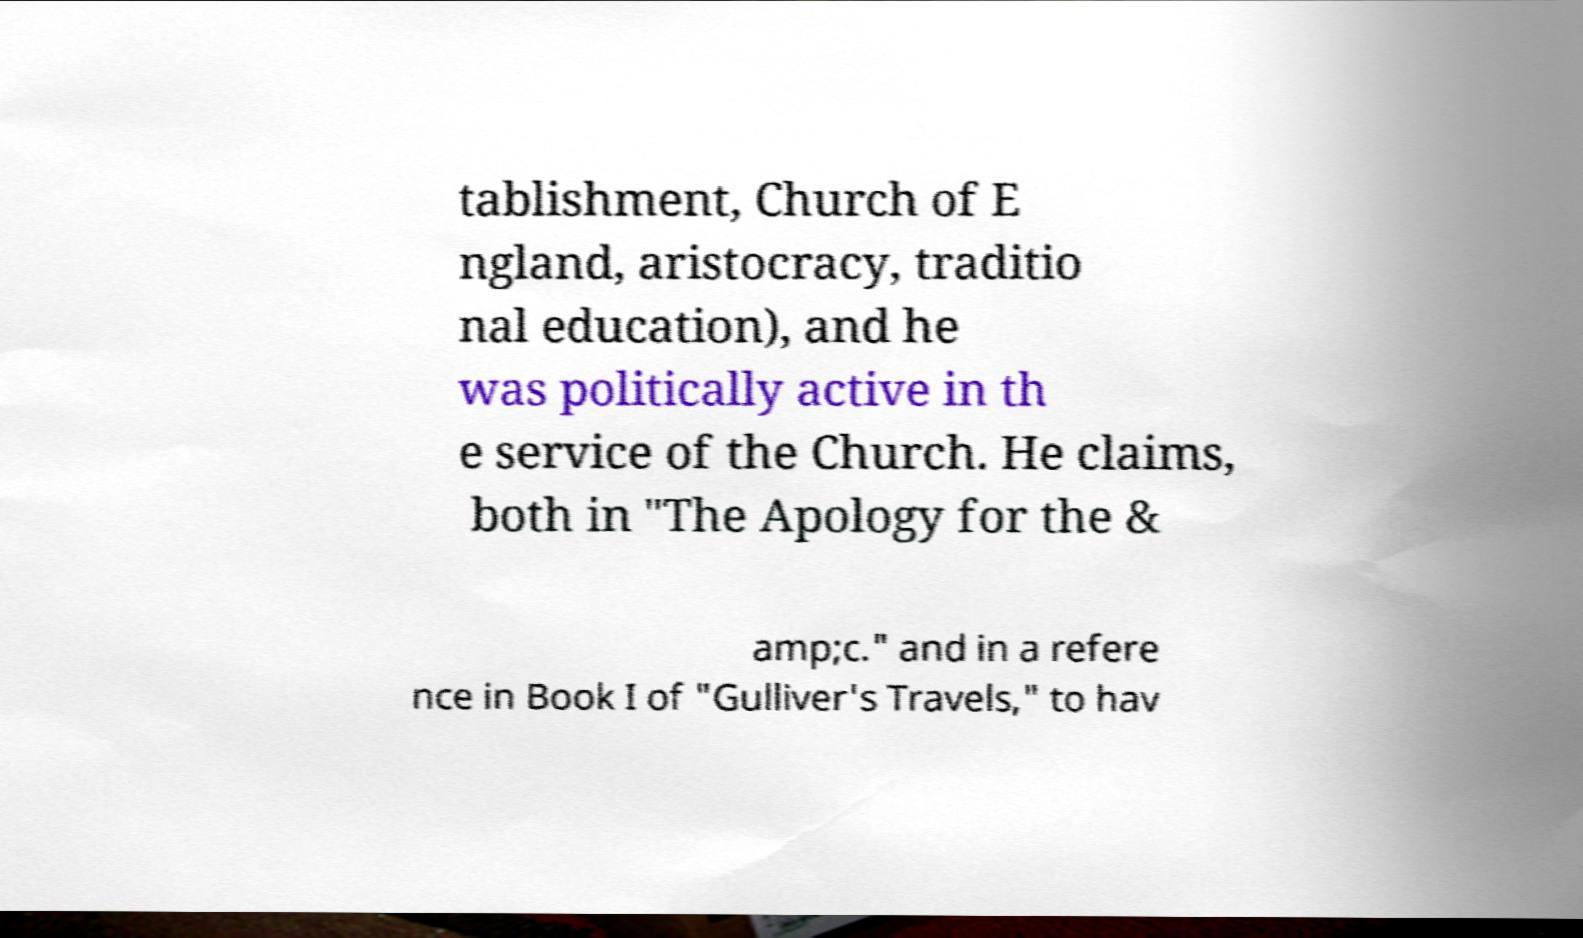Can you accurately transcribe the text from the provided image for me? tablishment, Church of E ngland, aristocracy, traditio nal education), and he was politically active in th e service of the Church. He claims, both in "The Apology for the & amp;c." and in a refere nce in Book I of "Gulliver's Travels," to hav 